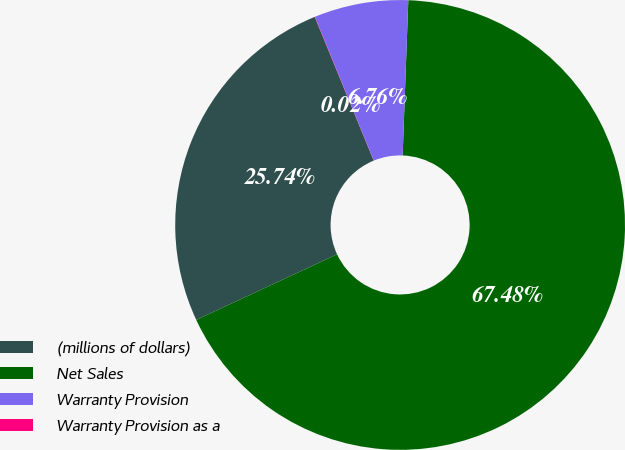Convert chart to OTSL. <chart><loc_0><loc_0><loc_500><loc_500><pie_chart><fcel>(millions of dollars)<fcel>Net Sales<fcel>Warranty Provision<fcel>Warranty Provision as a<nl><fcel>25.74%<fcel>67.48%<fcel>6.76%<fcel>0.02%<nl></chart> 